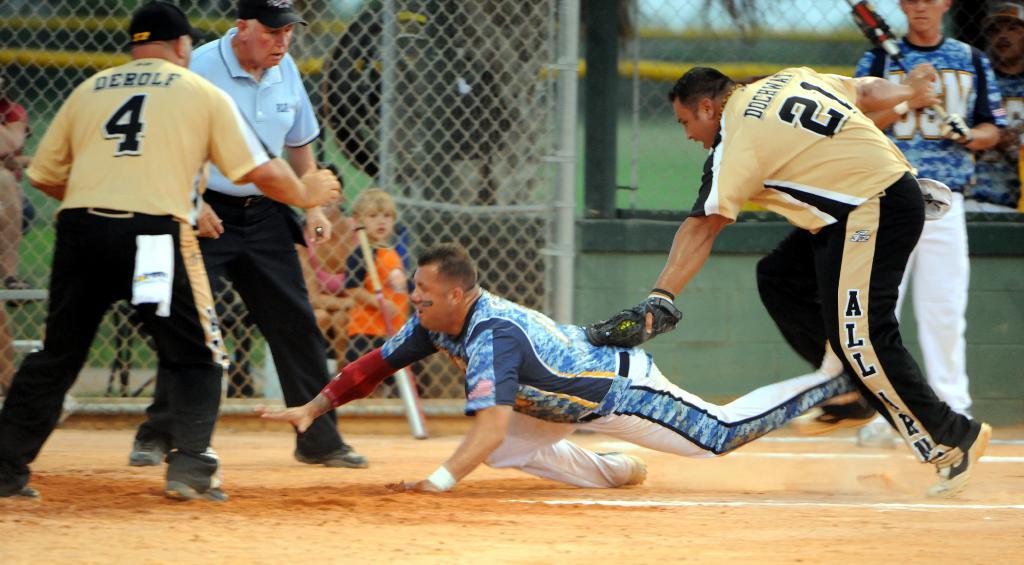What is the name of the player with a 4?
Make the answer very short. Derolf. 